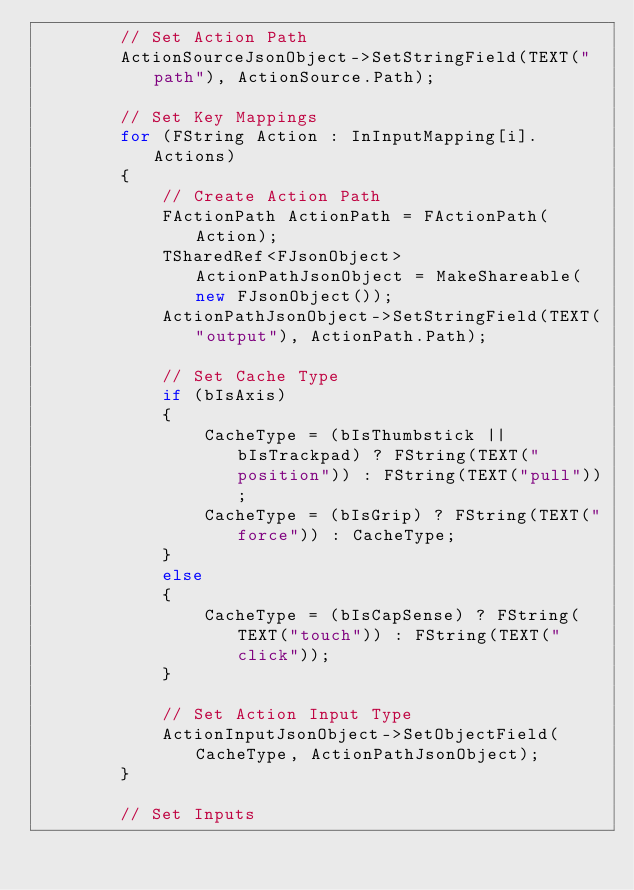<code> <loc_0><loc_0><loc_500><loc_500><_C++_>		// Set Action Path
		ActionSourceJsonObject->SetStringField(TEXT("path"), ActionSource.Path);

		// Set Key Mappings
		for (FString Action : InInputMapping[i].Actions)
		{
			// Create Action Path
			FActionPath ActionPath = FActionPath(Action);
			TSharedRef<FJsonObject> ActionPathJsonObject = MakeShareable(new FJsonObject());
			ActionPathJsonObject->SetStringField(TEXT("output"), ActionPath.Path);

			// Set Cache Type
			if (bIsAxis)
			{
				CacheType = (bIsThumbstick || bIsTrackpad) ? FString(TEXT("position")) : FString(TEXT("pull"));
				CacheType = (bIsGrip) ? FString(TEXT("force")) : CacheType;
			}
			else
			{
				CacheType = (bIsCapSense) ? FString(TEXT("touch")) : FString(TEXT("click"));
			}

			// Set Action Input Type
			ActionInputJsonObject->SetObjectField(CacheType, ActionPathJsonObject);
		}

		// Set Inputs</code> 